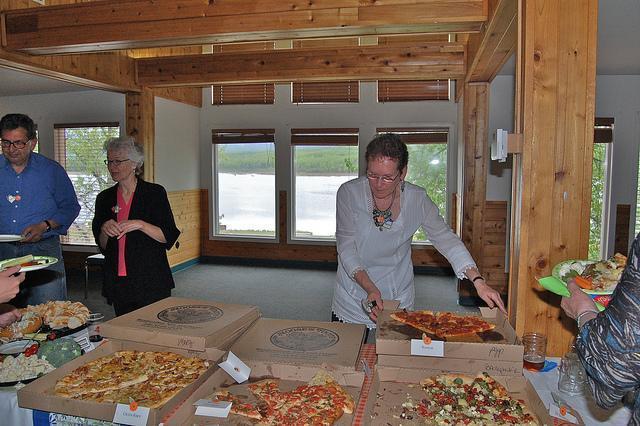How many people are wearing eyeglasses at the table?
Give a very brief answer. 3. How many people are in the photo?
Give a very brief answer. 4. How many pizzas can be seen?
Give a very brief answer. 3. 